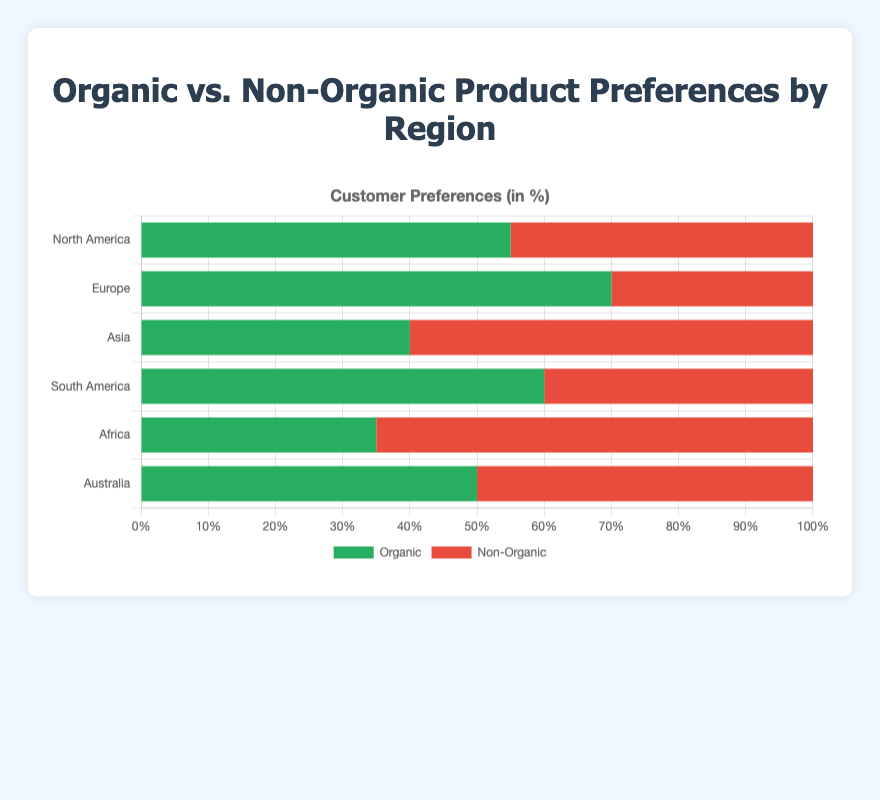What region has the highest preference for organic products? By examining the lengths of the green bars representing 'Organic', the longest bar corresponds to Europe with 70%.
Answer: Europe Which region has the lowest preference for organic products? By examining the lengths of the green bars representing 'Organic', the shortest bar corresponds to Africa with 35%.
Answer: Africa How much higher is the preference for organic products in Europe compared to Asia? Europe has 70% preference for organic products, while Asia has 40%. The difference is 70 - 40 = 30%.
Answer: 30% Which regions have an equal preference for organic and non-organic products? By looking for bars of equal length in both colors, only Australia has an equal preference, with 50% for each.
Answer: Australia What is the total percentage preference for organic products across all regions combined? Sum the preference percentages for organic products: 55 (North America) + 70 (Europe) + 40 (Asia) + 60 (South America) + 35 (Africa) + 50 (Australia) = 310%.
Answer: 310% How does the preference for non-organic products in South America compare to North America? In South America, the preference for non-organic products is 40%, while in North America, it is 45%. South America has a 5% lower preference for non-organic products.
Answer: 5% lower What region has the greatest preference for non-organic products compared to organic products? By comparing the lengths of red (non-organic) and green (organic) bars within each region, Africa has the greatest difference, with 65% non-organic and 35% organic, a difference of 30%.
Answer: Africa If you combined the organic preferences of North America and South America, what would be the total? North America has 55% and South America has 60% for organic preferences. Combined, this is 55 + 60 = 115%.
Answer: 115% Which region has a greater preference for non-organic products than Asia? From the non-organic bar lengths, Africa with 65% has a greater preference than Asia's 60%.
Answer: Africa What is the average preference for non-organic products across all regions? The preference percentages for non-organic products are: 45 (North America), 30 (Europe), 60 (Asia), 40 (South America), 65 (Africa), and 50 (Australia). The average is (45 + 30 + 60 + 40 + 65 + 50) / 6 ≈ 48.33%.
Answer: 48.33% 